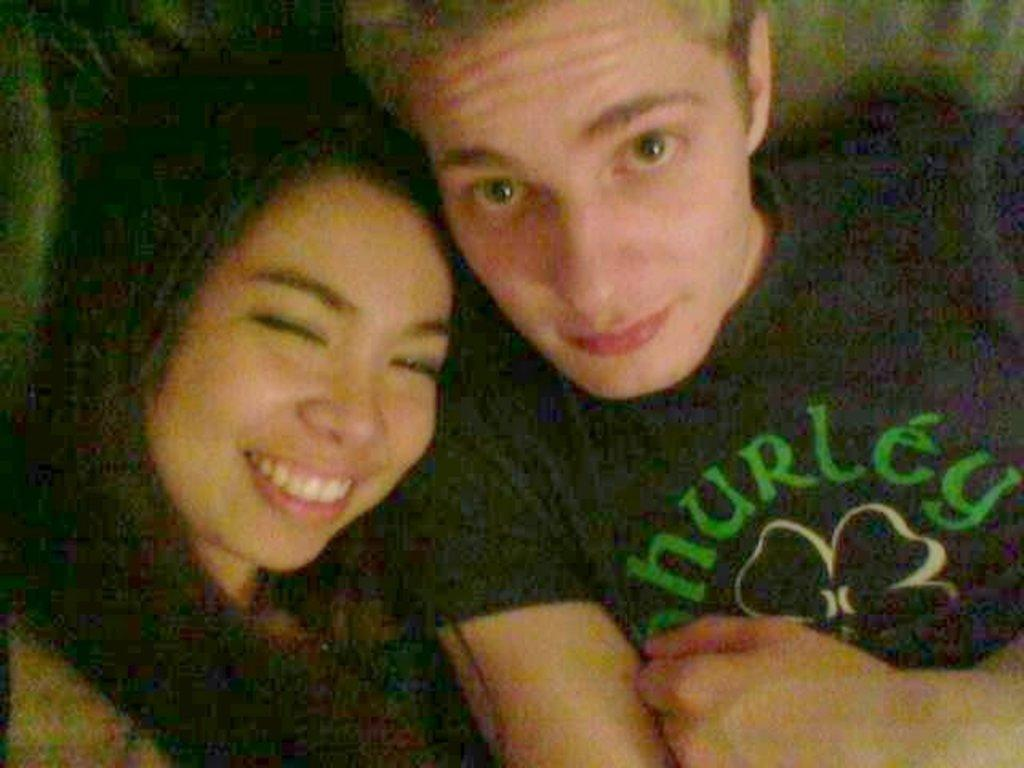Who is present in the image? There is a woman and a man in the image. What is the woman doing in the image? The woman is smiling in the image. How is the man dressed in the image? The man is wearing a black and green colored t-shirt in the image. What type of hose is the man using to water the plants in the image? There is no hose or plants present in the image; it only features a woman and a man. 